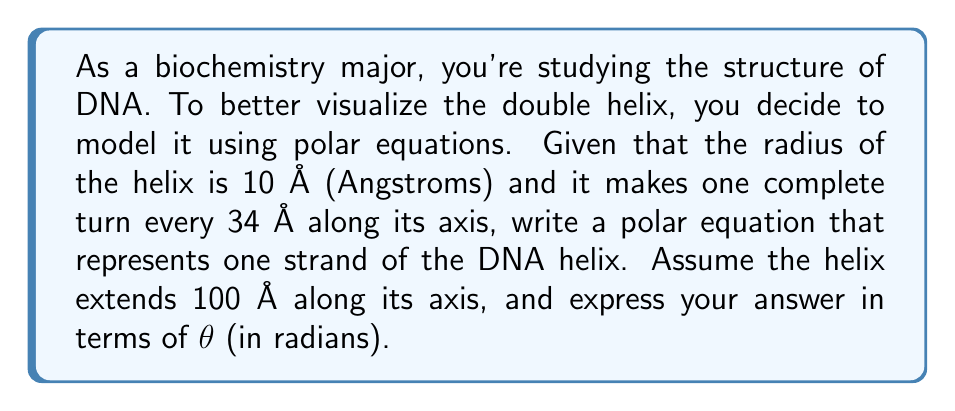Could you help me with this problem? To model the DNA helix using polar equations, we need to consider the following:

1) The radius of the helix is constant at 10 Å.
2) One complete turn occurs every 34 Å along the axis.
3) The helix extends 100 Å along its axis.

Let's approach this step-by-step:

1) In polar coordinates, we can represent a helix using the equation:
   
   $$r = a + b\theta$$

   where $a$ is the radius of the helix and $b$ is related to the pitch (vertical distance between turns).

2) We know $a = 10$ Å.

3) To find $b$, we need to consider the pitch of the helix:
   - One turn occurs every 34 Å along the axis
   - In one turn, $\theta$ increases by $2\pi$ radians
   
   So, $b = \frac{34}{2\pi}$ Å/radian

4) Now, we need to adjust for the total length of 100 Å:
   - Number of turns = $\frac{100 \text{ Å}}{34 \text{ Å/turn}} \approx 2.94$ turns
   - Total angle: $2.94 \cdot 2\pi \approx 18.47$ radians

5) Therefore, our equation will be valid for $0 \leq \theta \leq 18.47$

6) Putting it all together, our polar equation is:

   $$r = 10 + \frac{34}{2\pi}\theta$$

   for $0 \leq \theta \leq 18.47$

This equation represents one strand of the DNA helix in polar coordinates.
Answer: $$r = 10 + \frac{34}{2\pi}\theta, \quad 0 \leq \theta \leq 18.47$$

where $r$ is in Angstroms and $\theta$ is in radians. 